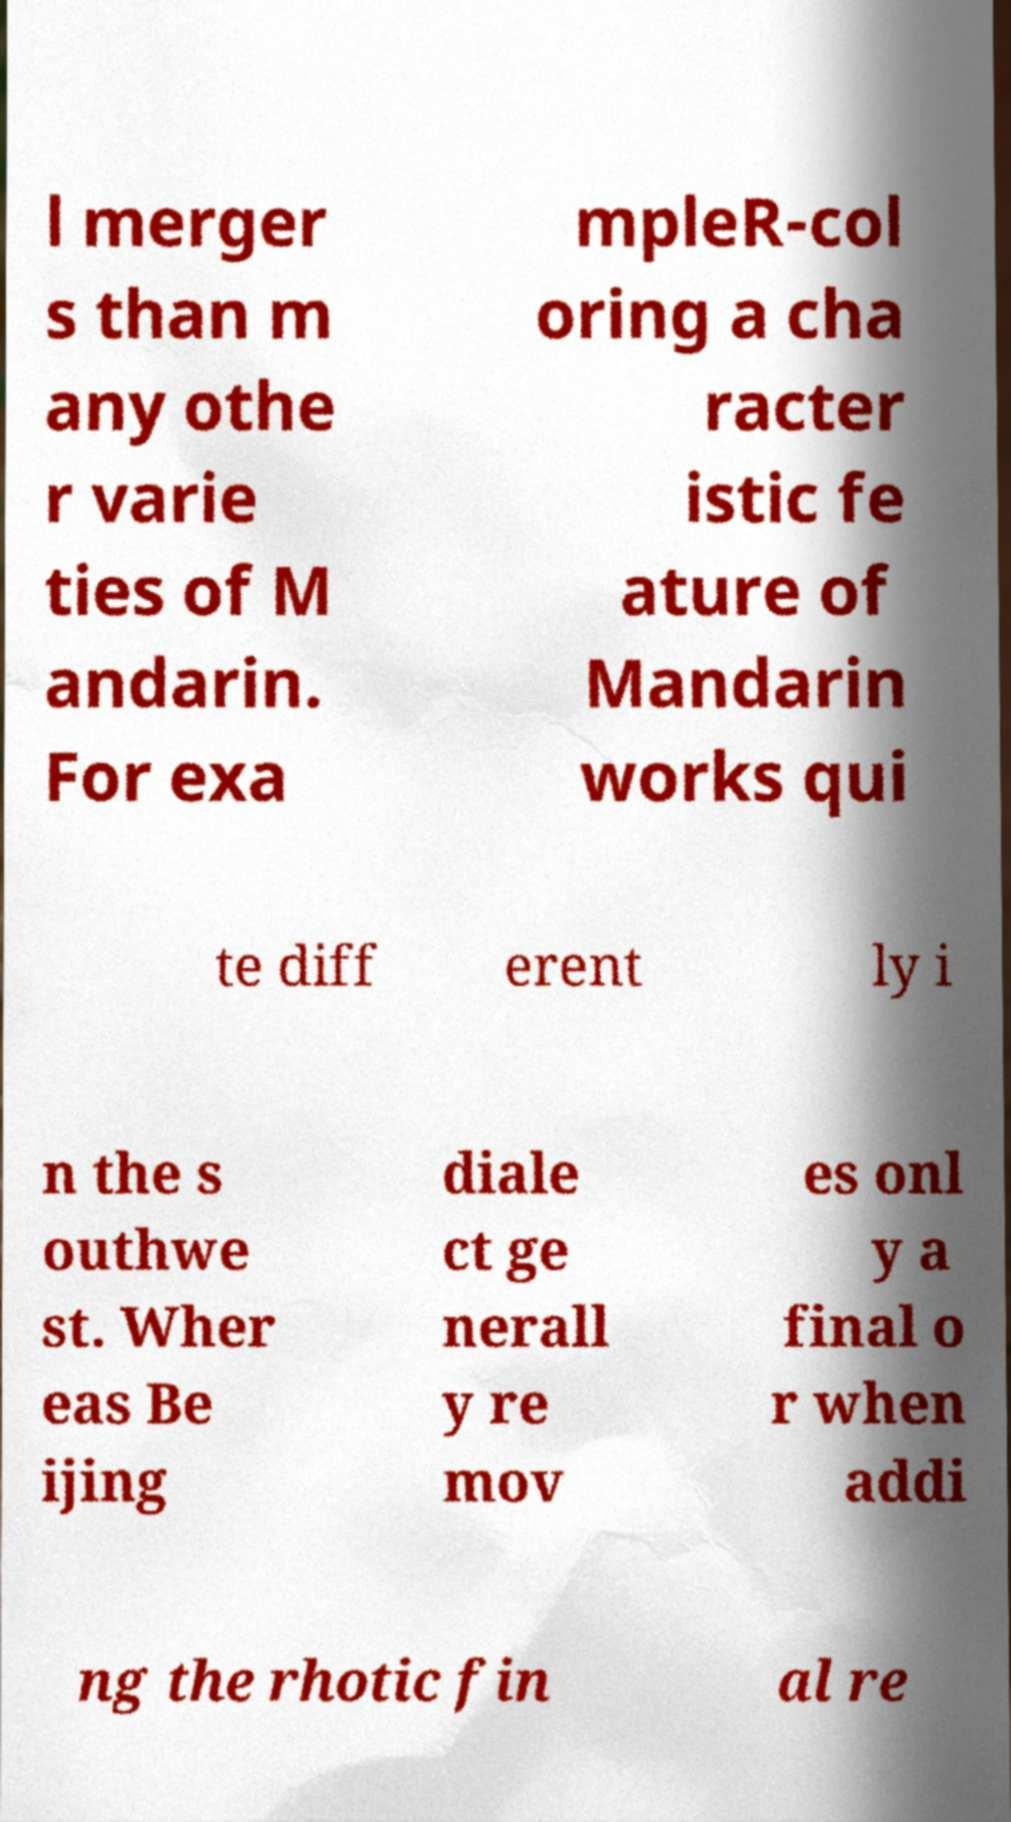Could you extract and type out the text from this image? l merger s than m any othe r varie ties of M andarin. For exa mpleR-col oring a cha racter istic fe ature of Mandarin works qui te diff erent ly i n the s outhwe st. Wher eas Be ijing diale ct ge nerall y re mov es onl y a final o r when addi ng the rhotic fin al re 